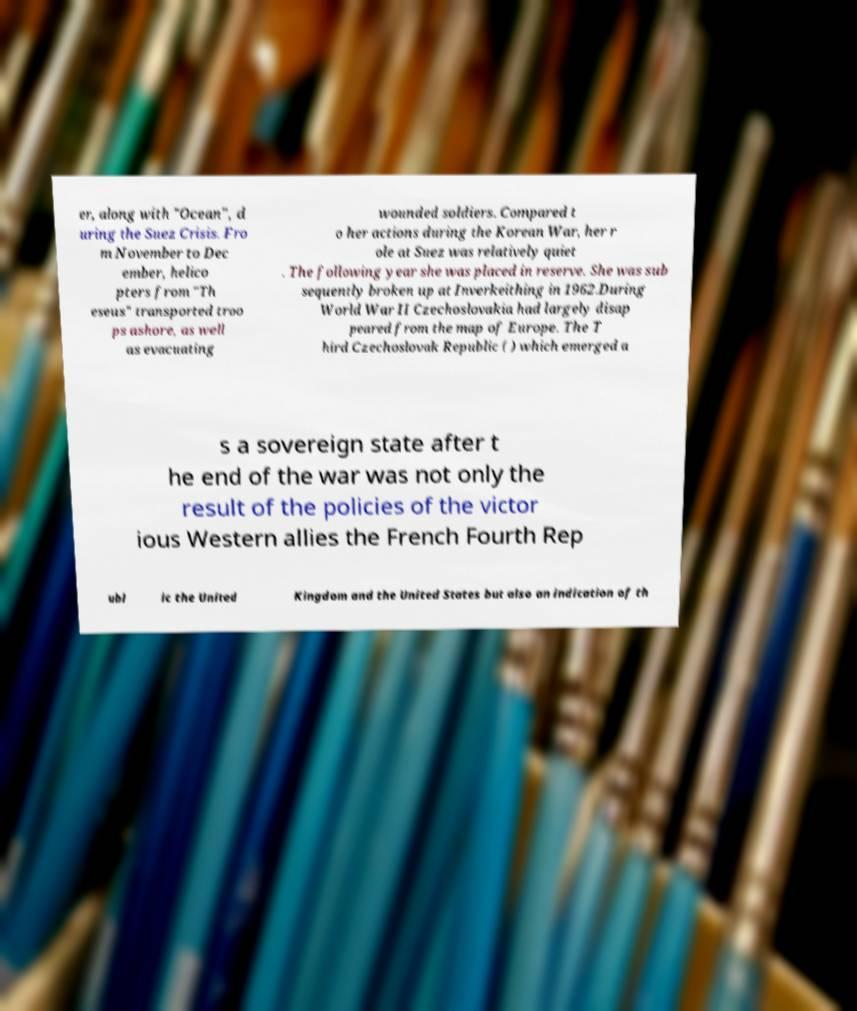Please identify and transcribe the text found in this image. er, along with "Ocean", d uring the Suez Crisis. Fro m November to Dec ember, helico pters from "Th eseus" transported troo ps ashore, as well as evacuating wounded soldiers. Compared t o her actions during the Korean War, her r ole at Suez was relatively quiet . The following year she was placed in reserve. She was sub sequently broken up at Inverkeithing in 1962.During World War II Czechoslovakia had largely disap peared from the map of Europe. The T hird Czechoslovak Republic ( ) which emerged a s a sovereign state after t he end of the war was not only the result of the policies of the victor ious Western allies the French Fourth Rep ubl ic the United Kingdom and the United States but also an indication of th 